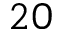Convert formula to latex. <formula><loc_0><loc_0><loc_500><loc_500>2 0</formula> 